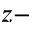Convert formula to latex. <formula><loc_0><loc_0><loc_500><loc_500>z -</formula> 